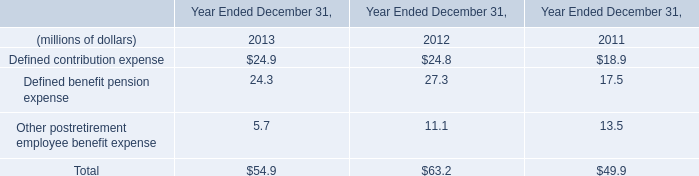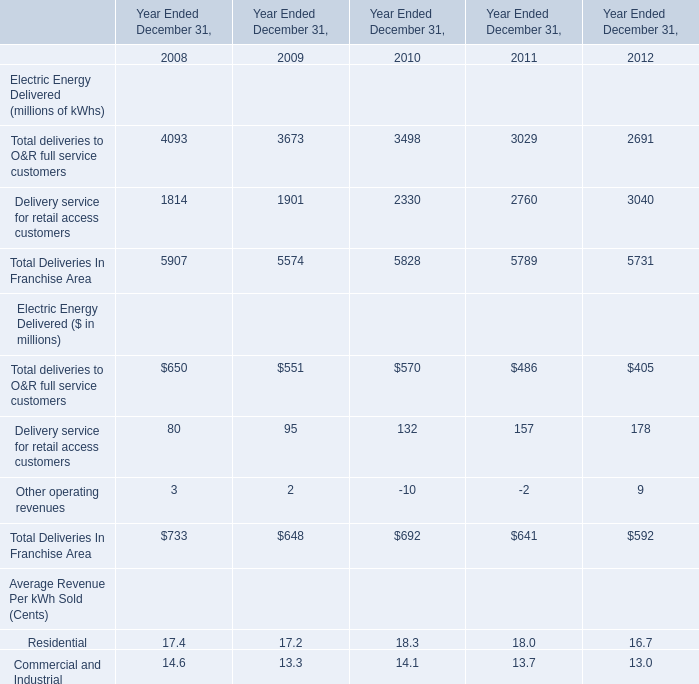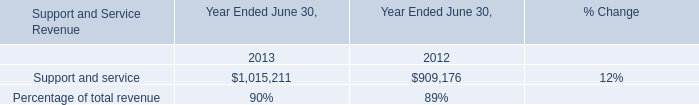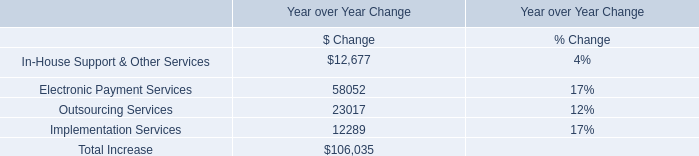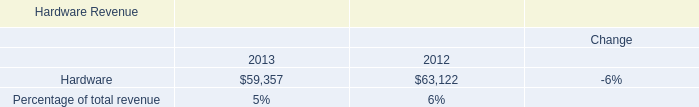In the year with the most Delivery service for retail access customers, what is the growth rate of Total deliveries to O&R full service customers? 
Computations: ((405 - 486) / 486)
Answer: -0.16667. 